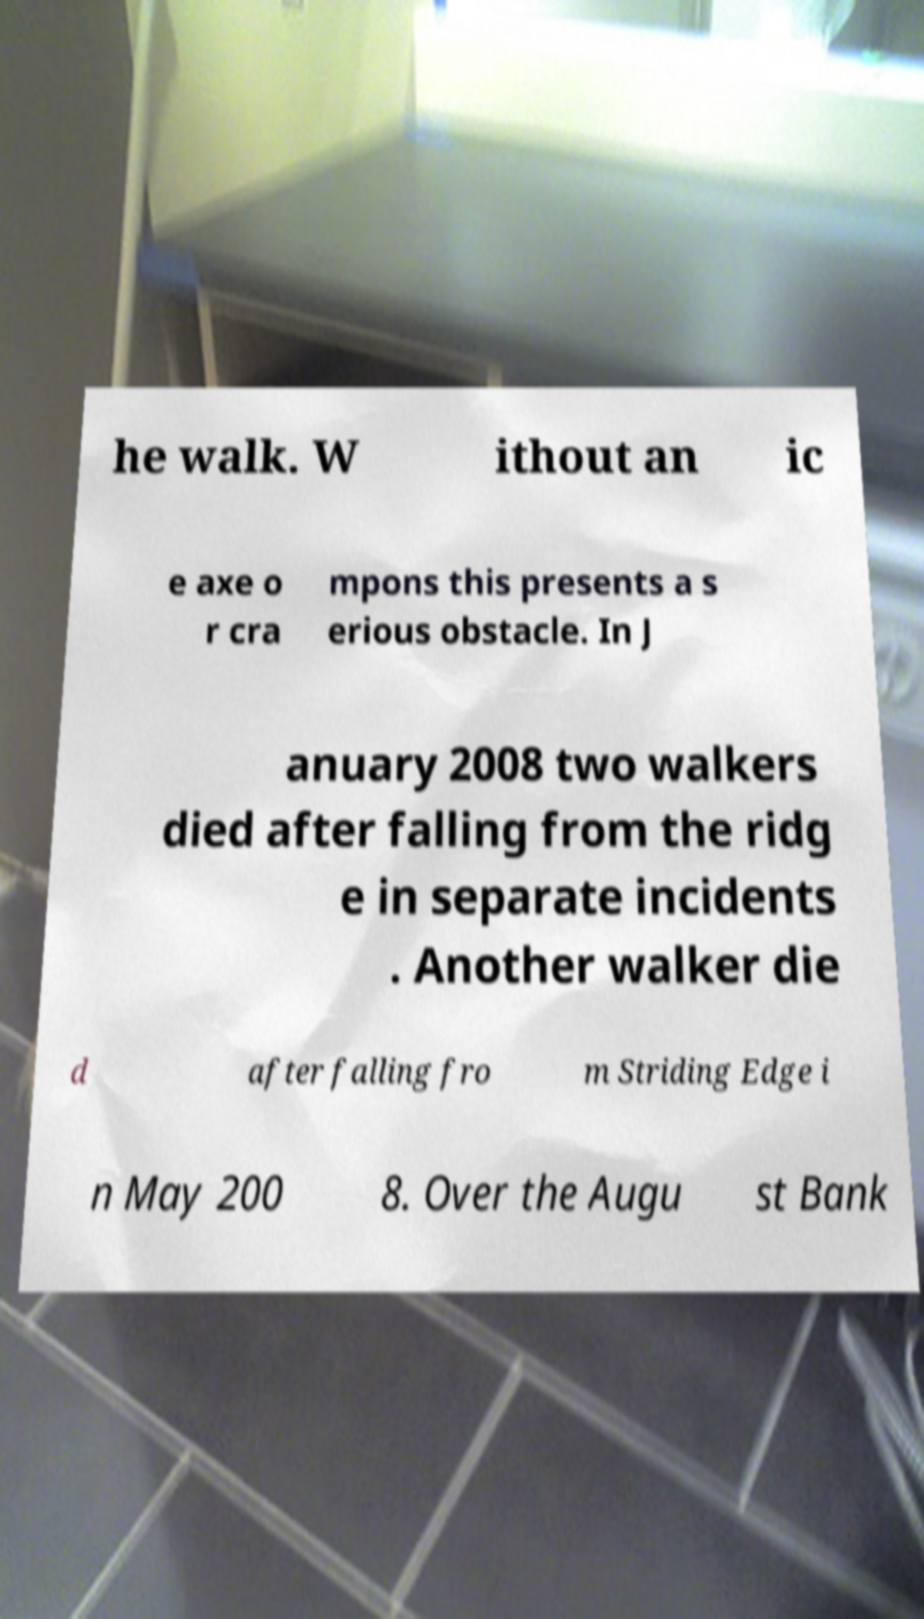Please read and relay the text visible in this image. What does it say? he walk. W ithout an ic e axe o r cra mpons this presents a s erious obstacle. In J anuary 2008 two walkers died after falling from the ridg e in separate incidents . Another walker die d after falling fro m Striding Edge i n May 200 8. Over the Augu st Bank 